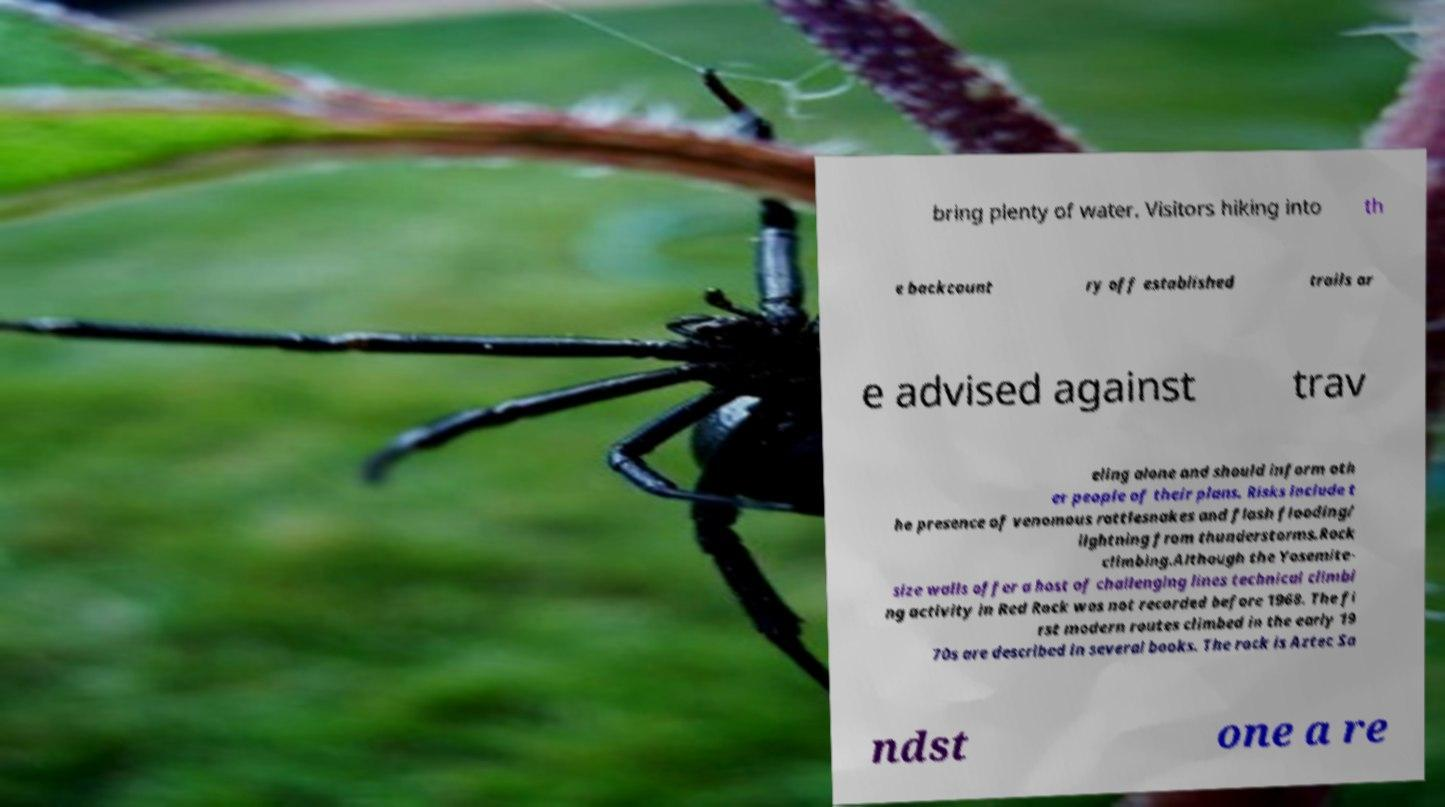Could you extract and type out the text from this image? bring plenty of water. Visitors hiking into th e backcount ry off established trails ar e advised against trav eling alone and should inform oth er people of their plans. Risks include t he presence of venomous rattlesnakes and flash flooding/ lightning from thunderstorms.Rock climbing.Although the Yosemite- size walls offer a host of challenging lines technical climbi ng activity in Red Rock was not recorded before 1968. The fi rst modern routes climbed in the early 19 70s are described in several books. The rock is Aztec Sa ndst one a re 